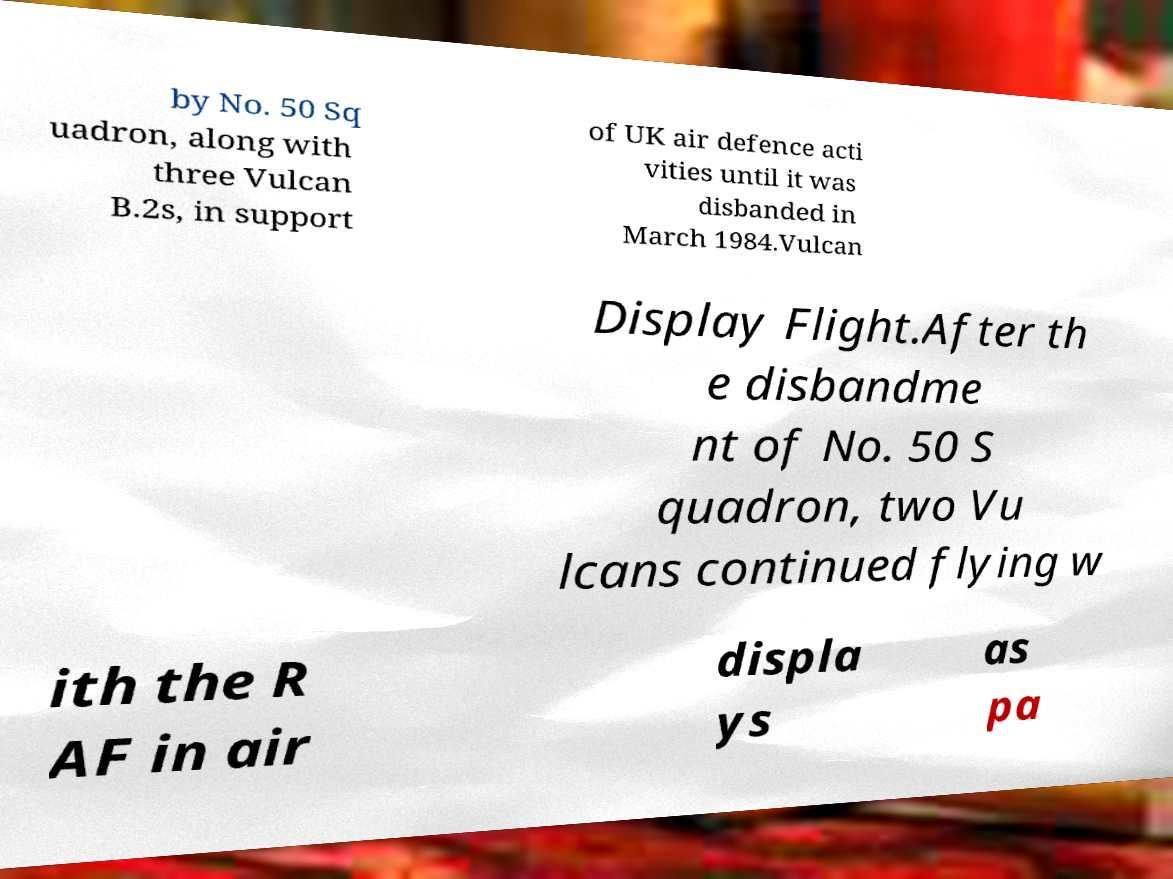Can you read and provide the text displayed in the image?This photo seems to have some interesting text. Can you extract and type it out for me? by No. 50 Sq uadron, along with three Vulcan B.2s, in support of UK air defence acti vities until it was disbanded in March 1984.Vulcan Display Flight.After th e disbandme nt of No. 50 S quadron, two Vu lcans continued flying w ith the R AF in air displa ys as pa 